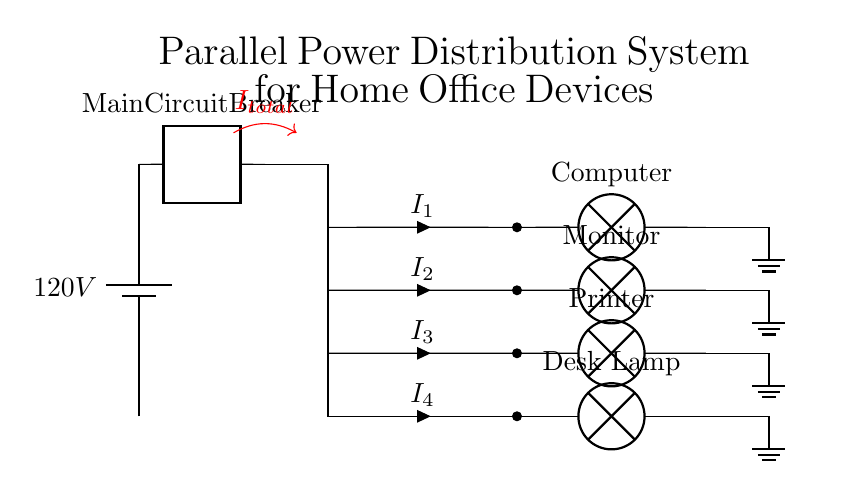What is the total voltage in this circuit? The total voltage is determined by the main power source, which is labeled as 120V. Since the voltage in parallel circuits remains the same across all branches, the voltage for each device is also 120V.
Answer: 120V What type of current distribution is depicted? This circuit shows parallel distribution where multiple loads (devices) share the same voltage from the main power source while drawing different currents. In parallel circuits, the total current is the sum of the currents through each branch.
Answer: Parallel How many devices are connected to the power source? The diagram displays four devices connected to the power source: a computer, a monitor, a printer, and a desk lamp. Each device has its own branch coming from the main circuit.
Answer: Four What is the significance of the ground connections in this circuit? The ground connections provide a safety path for fault currents and ensure that the circuit is at a common reference point. This is important for protecting devices from electrical shock or damage.
Answer: Safety What does the notation "I_total" represent in the circuit? "I_total" indicates the total current flowing from the main circuit breaker into the parallel branches. It signifies the combined effect of the individual currents flowing through each device's branch. This is essential for verifying whether the circuit is within the load capacity.
Answer: Total current What does each "I" represent in the branches? Each "I" represents the current flowing through each individual device: I1 for the computer, I2 for the monitor, I3 for the printer, and I4 for the desk lamp. In a parallel circuit, these currents can vary based on the devices' power requirements.
Answer: Individual currents What would happen if one device fails in this circuit? If one device fails (i.e., opens its circuit), the other devices would continue to operate normally because the connections are in parallel. This characteristic is a significant advantage of parallel circuits compared to series circuits, where a failure stops the entire current flow.
Answer: Continuity of operation 